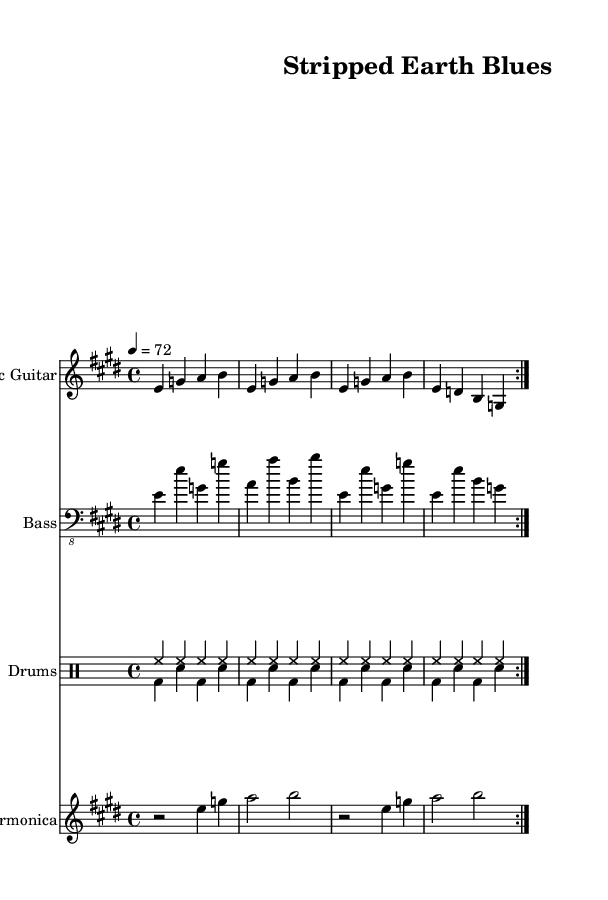What is the key signature of this music? The key signature is E major, which has four sharps: F#, C#, G#, and D#.
Answer: E major What is the time signature of this piece? The time signature shown in the score is 4/4, indicating four beats per measure.
Answer: 4/4 What is the tempo marking for this composition? The tempo marking is 72 beats per minute, defined as a moderate tempo.
Answer: 72 How many measures are in the repeated section of the electric guitar part? The electric guitar part consists of 8 measures, as it is repeated twice with 4 measures each time.
Answer: 8 measures What instruments are included in this score? The instruments present in the score are Electric Guitar, Bass, Drums, and Harmonica, which are typical of the Electric Blues genre.
Answer: Electric Guitar, Bass, Drums, Harmonica What rhythmic value does the harmonica play in the first measure? In the first measure, the harmonica starts with a rest followed by an eighth note (the note E), making the total duration two beats.
Answer: Rest, E What type of musical form does the structure of the music follow? The score indicates a repeated section (volta), typical of blues music, which often features repetitive and cyclic structures.
Answer: Repeated section 